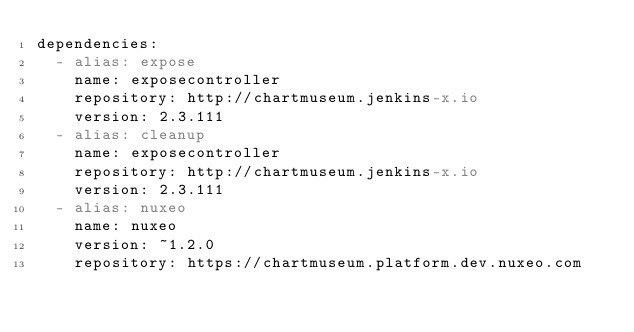<code> <loc_0><loc_0><loc_500><loc_500><_YAML_>dependencies:
  - alias: expose
    name: exposecontroller
    repository: http://chartmuseum.jenkins-x.io
    version: 2.3.111
  - alias: cleanup
    name: exposecontroller
    repository: http://chartmuseum.jenkins-x.io
    version: 2.3.111
  - alias: nuxeo
    name: nuxeo
    version: ~1.2.0
    repository: https://chartmuseum.platform.dev.nuxeo.com
</code> 